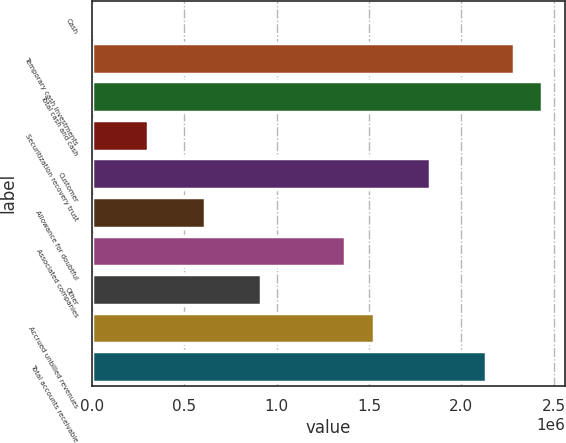Convert chart. <chart><loc_0><loc_0><loc_500><loc_500><bar_chart><fcel>Cash<fcel>Temporary cash investments<fcel>Total cash and cash<fcel>Securitization recovery trust<fcel>Customer<fcel>Allowance for doubtful<fcel>Associated companies<fcel>Other<fcel>Accrued unbilled revenues<fcel>Total accounts receivable<nl><fcel>28<fcel>2.28646e+06<fcel>2.43889e+06<fcel>304886<fcel>1.82917e+06<fcel>609744<fcel>1.37189e+06<fcel>914601<fcel>1.52432e+06<fcel>2.13403e+06<nl></chart> 